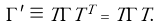<formula> <loc_0><loc_0><loc_500><loc_500>\Gamma ^ { \prime } \equiv T \Gamma T ^ { T } = T \Gamma T .</formula> 